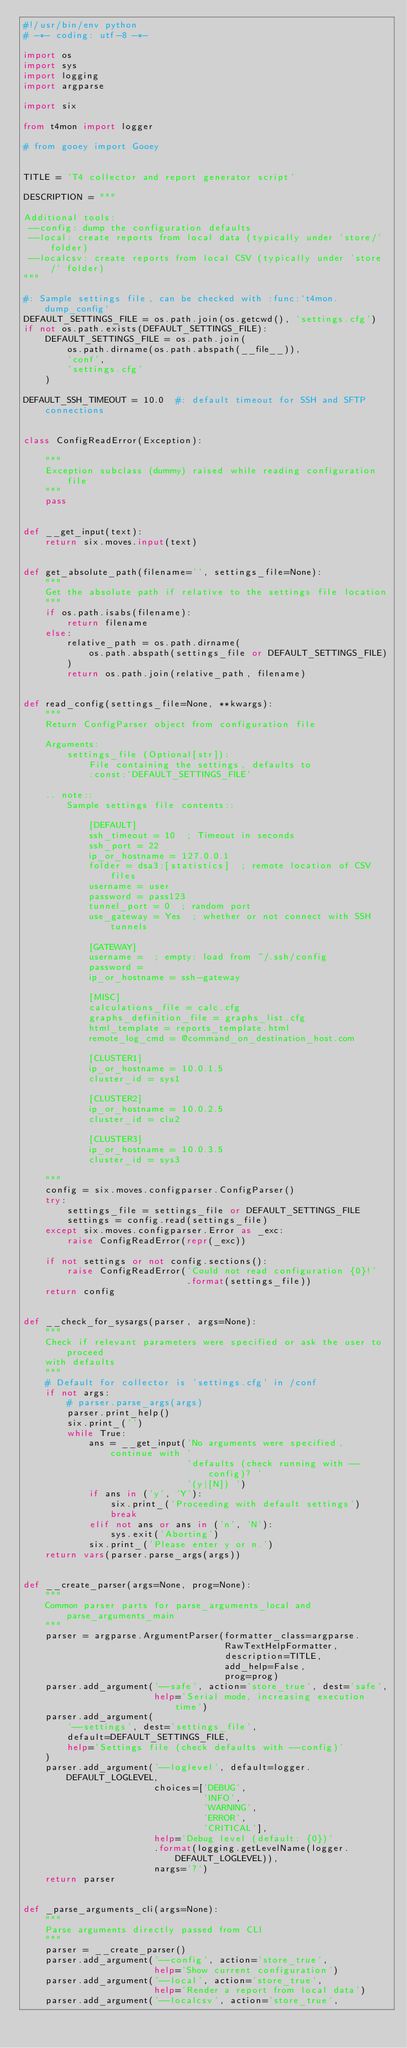Convert code to text. <code><loc_0><loc_0><loc_500><loc_500><_Python_>#!/usr/bin/env python
# -*- coding: utf-8 -*-

import os
import sys
import logging
import argparse

import six

from t4mon import logger

# from gooey import Gooey


TITLE = 'T4 collector and report generator script'

DESCRIPTION = """

Additional tools:
 --config: dump the configuration defaults
 --local: create reports from local data (typically under 'store/' folder)
 --localcsv: create reports from local CSV (typically under 'store/' folder)
"""

#: Sample settings file, can be checked with :func:`t4mon.dump_config`
DEFAULT_SETTINGS_FILE = os.path.join(os.getcwd(), 'settings.cfg')
if not os.path.exists(DEFAULT_SETTINGS_FILE):
    DEFAULT_SETTINGS_FILE = os.path.join(
        os.path.dirname(os.path.abspath(__file__)),
        'conf',
        'settings.cfg'
    )

DEFAULT_SSH_TIMEOUT = 10.0  #: default timeout for SSH and SFTP connections


class ConfigReadError(Exception):

    """
    Exception subclass (dummy) raised while reading configuration file
    """
    pass


def __get_input(text):
    return six.moves.input(text)


def get_absolute_path(filename='', settings_file=None):
    """
    Get the absolute path if relative to the settings file location
    """
    if os.path.isabs(filename):
        return filename
    else:
        relative_path = os.path.dirname(
            os.path.abspath(settings_file or DEFAULT_SETTINGS_FILE)
        )
        return os.path.join(relative_path, filename)


def read_config(settings_file=None, **kwargs):
    """
    Return ConfigParser object from configuration file

    Arguments:
        settings_file (Optional[str]):
            File containing the settings, defaults to
            :const:`DEFAULT_SETTINGS_FILE`

    .. note::
        Sample settings file contents::

            [DEFAULT]
            ssh_timeout = 10  ; Timeout in seconds
            ssh_port = 22
            ip_or_hostname = 127.0.0.1
            folder = dsa3:[statistics]  ; remote location of CSV files
            username = user
            password = pass123
            tunnel_port = 0  ; random port
            use_gateway = Yes  ; whether or not connect with SSH tunnels

            [GATEWAY]
            username =  ; empty: load from ~/.ssh/config
            password =
            ip_or_hostname = ssh-gateway

            [MISC]
            calculations_file = calc.cfg
            graphs_definition_file = graphs_list.cfg
            html_template = reports_template.html
            remote_log_cmd = @command_on_destination_host.com

            [CLUSTER1]
            ip_or_hostname = 10.0.1.5
            cluster_id = sys1

            [CLUSTER2]
            ip_or_hostname = 10.0.2.5
            cluster_id = clu2

            [CLUSTER3]
            ip_or_hostname = 10.0.3.5
            cluster_id = sys3

    """
    config = six.moves.configparser.ConfigParser()
    try:
        settings_file = settings_file or DEFAULT_SETTINGS_FILE
        settings = config.read(settings_file)
    except six.moves.configparser.Error as _exc:
        raise ConfigReadError(repr(_exc))

    if not settings or not config.sections():
        raise ConfigReadError('Could not read configuration {0}!'
                              .format(settings_file))
    return config


def __check_for_sysargs(parser, args=None):
    """
    Check if relevant parameters were specified or ask the user to proceed
    with defaults
    """
    # Default for collector is 'settings.cfg' in /conf
    if not args:
        # parser.parse_args(args)
        parser.print_help()
        six.print_('')
        while True:
            ans = __get_input('No arguments were specified, continue with '
                              'defaults (check running with --config)? '
                              '(y|[N]) ')
            if ans in ('y', 'Y'):
                six.print_('Proceeding with default settings')
                break
            elif not ans or ans in ('n', 'N'):
                sys.exit('Aborting')
            six.print_('Please enter y or n.')
    return vars(parser.parse_args(args))


def __create_parser(args=None, prog=None):
    """
    Common parser parts for parse_arguments_local and parse_arguments_main
    """
    parser = argparse.ArgumentParser(formatter_class=argparse.
                                     RawTextHelpFormatter,
                                     description=TITLE,
                                     add_help=False,
                                     prog=prog)
    parser.add_argument('--safe', action='store_true', dest='safe',
                        help='Serial mode, increasing execution time')
    parser.add_argument(
        '--settings', dest='settings_file',
        default=DEFAULT_SETTINGS_FILE,
        help='Settings file (check defaults with --config)'
    )
    parser.add_argument('--loglevel', default=logger.DEFAULT_LOGLEVEL,
                        choices=['DEBUG',
                                 'INFO',
                                 'WARNING',
                                 'ERROR',
                                 'CRITICAL'],
                        help='Debug level (default: {0})'
                        .format(logging.getLevelName(logger.DEFAULT_LOGLEVEL)),
                        nargs='?')
    return parser


def _parse_arguments_cli(args=None):
    """
    Parse arguments directly passed from CLI
    """
    parser = __create_parser()
    parser.add_argument('--config', action='store_true',
                        help='Show current configuration')
    parser.add_argument('--local', action='store_true',
                        help='Render a report from local data')
    parser.add_argument('--localcsv', action='store_true',</code> 